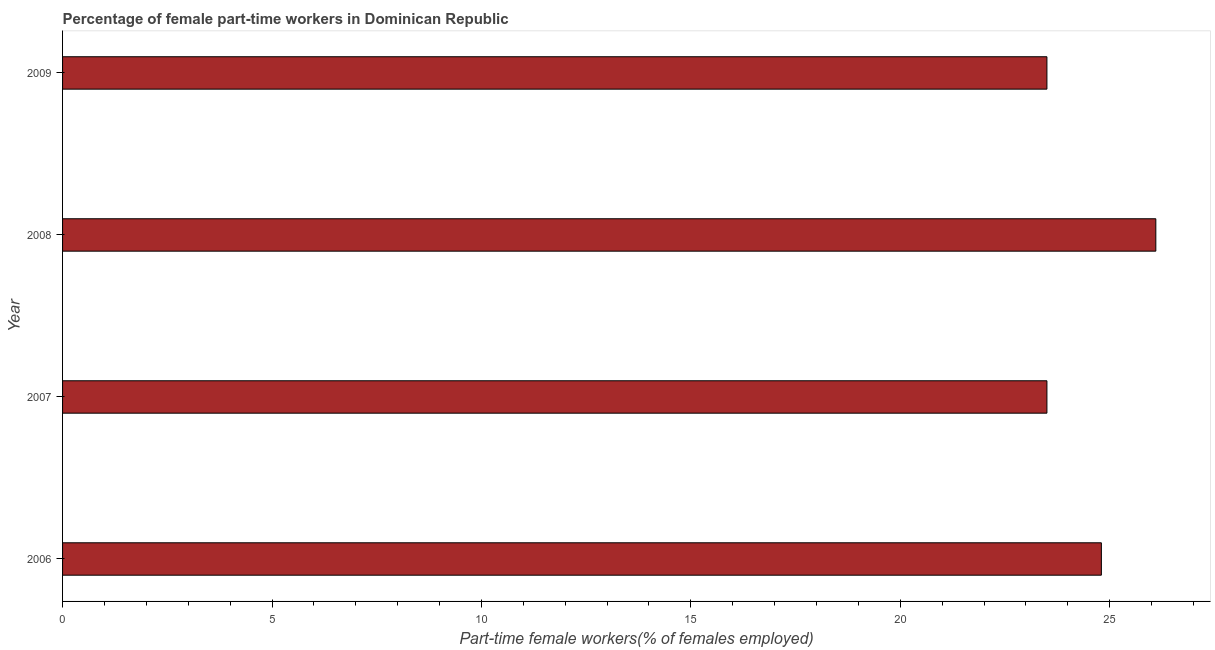Does the graph contain grids?
Provide a succinct answer. No. What is the title of the graph?
Make the answer very short. Percentage of female part-time workers in Dominican Republic. What is the label or title of the X-axis?
Provide a short and direct response. Part-time female workers(% of females employed). What is the percentage of part-time female workers in 2008?
Keep it short and to the point. 26.1. Across all years, what is the maximum percentage of part-time female workers?
Your answer should be very brief. 26.1. In which year was the percentage of part-time female workers maximum?
Your answer should be very brief. 2008. What is the sum of the percentage of part-time female workers?
Provide a succinct answer. 97.9. What is the difference between the percentage of part-time female workers in 2006 and 2007?
Keep it short and to the point. 1.3. What is the average percentage of part-time female workers per year?
Give a very brief answer. 24.48. What is the median percentage of part-time female workers?
Provide a succinct answer. 24.15. Do a majority of the years between 2008 and 2007 (inclusive) have percentage of part-time female workers greater than 7 %?
Offer a terse response. No. What is the ratio of the percentage of part-time female workers in 2008 to that in 2009?
Your answer should be compact. 1.11. Is the difference between the percentage of part-time female workers in 2007 and 2008 greater than the difference between any two years?
Offer a terse response. Yes. What is the difference between the highest and the second highest percentage of part-time female workers?
Your answer should be compact. 1.3. Is the sum of the percentage of part-time female workers in 2007 and 2009 greater than the maximum percentage of part-time female workers across all years?
Keep it short and to the point. Yes. How many bars are there?
Provide a succinct answer. 4. How many years are there in the graph?
Give a very brief answer. 4. Are the values on the major ticks of X-axis written in scientific E-notation?
Offer a very short reply. No. What is the Part-time female workers(% of females employed) in 2006?
Provide a succinct answer. 24.8. What is the Part-time female workers(% of females employed) in 2007?
Your answer should be compact. 23.5. What is the Part-time female workers(% of females employed) in 2008?
Keep it short and to the point. 26.1. What is the Part-time female workers(% of females employed) in 2009?
Make the answer very short. 23.5. What is the difference between the Part-time female workers(% of females employed) in 2006 and 2007?
Your answer should be compact. 1.3. What is the difference between the Part-time female workers(% of females employed) in 2006 and 2008?
Provide a short and direct response. -1.3. What is the difference between the Part-time female workers(% of females employed) in 2006 and 2009?
Provide a short and direct response. 1.3. What is the difference between the Part-time female workers(% of females employed) in 2007 and 2009?
Provide a short and direct response. 0. What is the ratio of the Part-time female workers(% of females employed) in 2006 to that in 2007?
Give a very brief answer. 1.05. What is the ratio of the Part-time female workers(% of females employed) in 2006 to that in 2009?
Ensure brevity in your answer.  1.05. What is the ratio of the Part-time female workers(% of females employed) in 2007 to that in 2009?
Give a very brief answer. 1. What is the ratio of the Part-time female workers(% of females employed) in 2008 to that in 2009?
Make the answer very short. 1.11. 